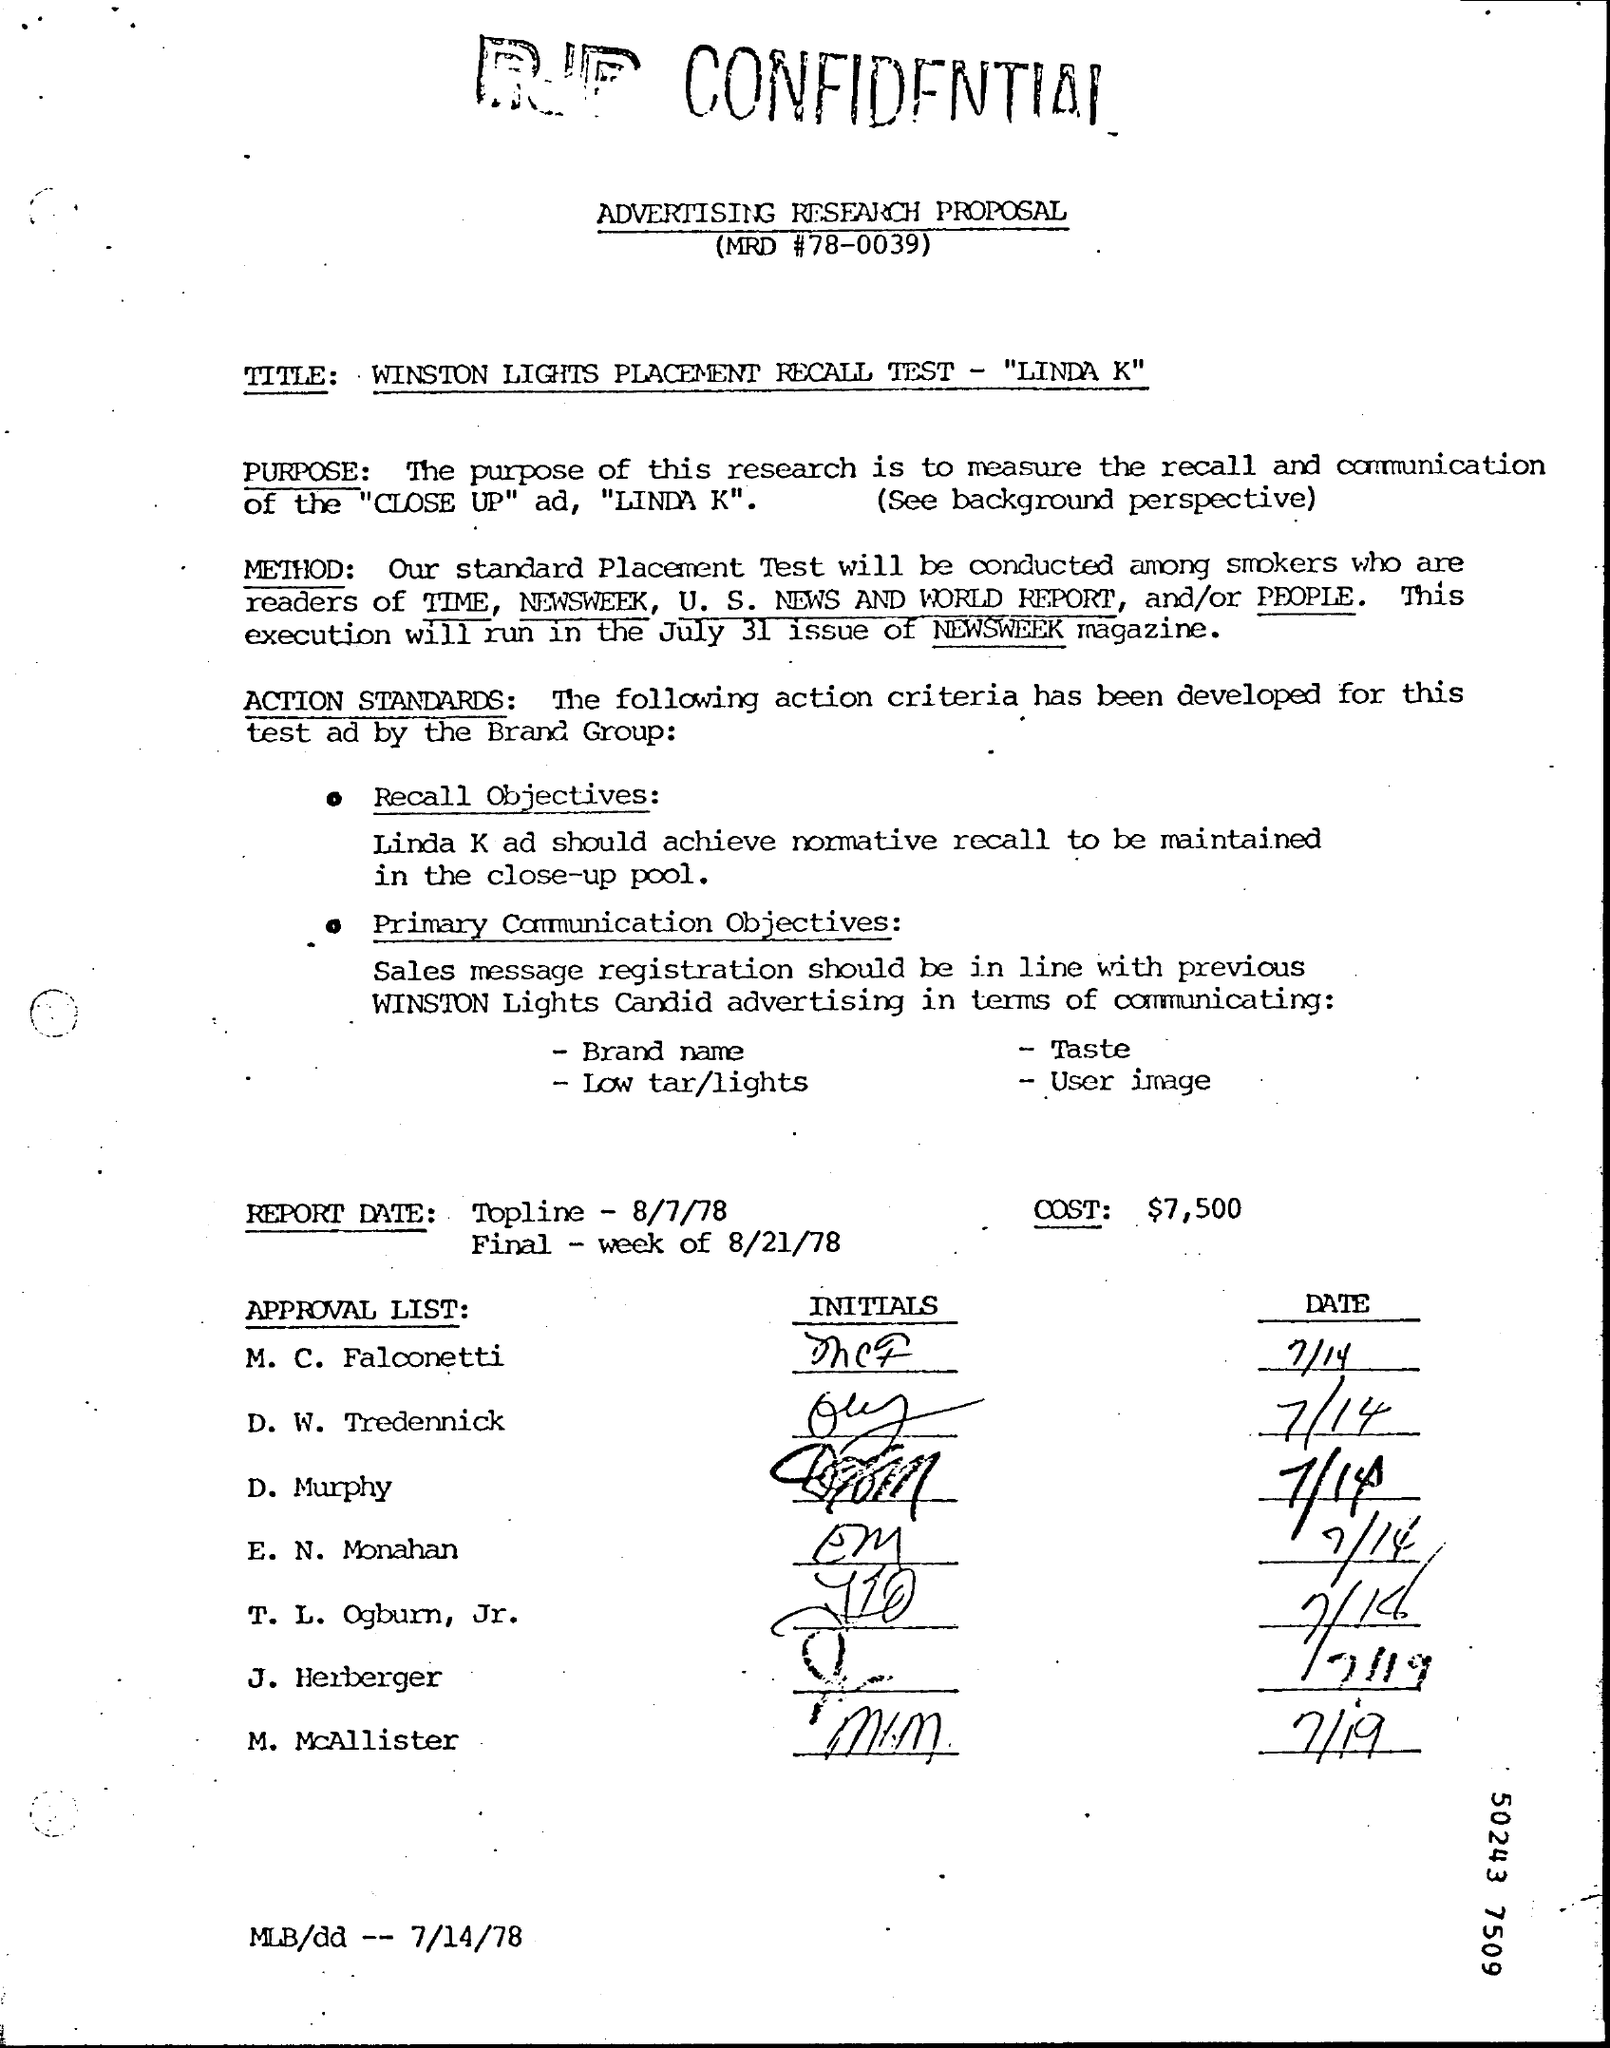Draw attention to some important aspects in this diagram. The MRD number is 78-0039. What is the meaning of the abbreviation 'low tar/lights' in a user image? The Report Date Topline is August 7th, 1978. The cost is $7,500. What is the Report Date Final? It is the week of August 21, 1978. 